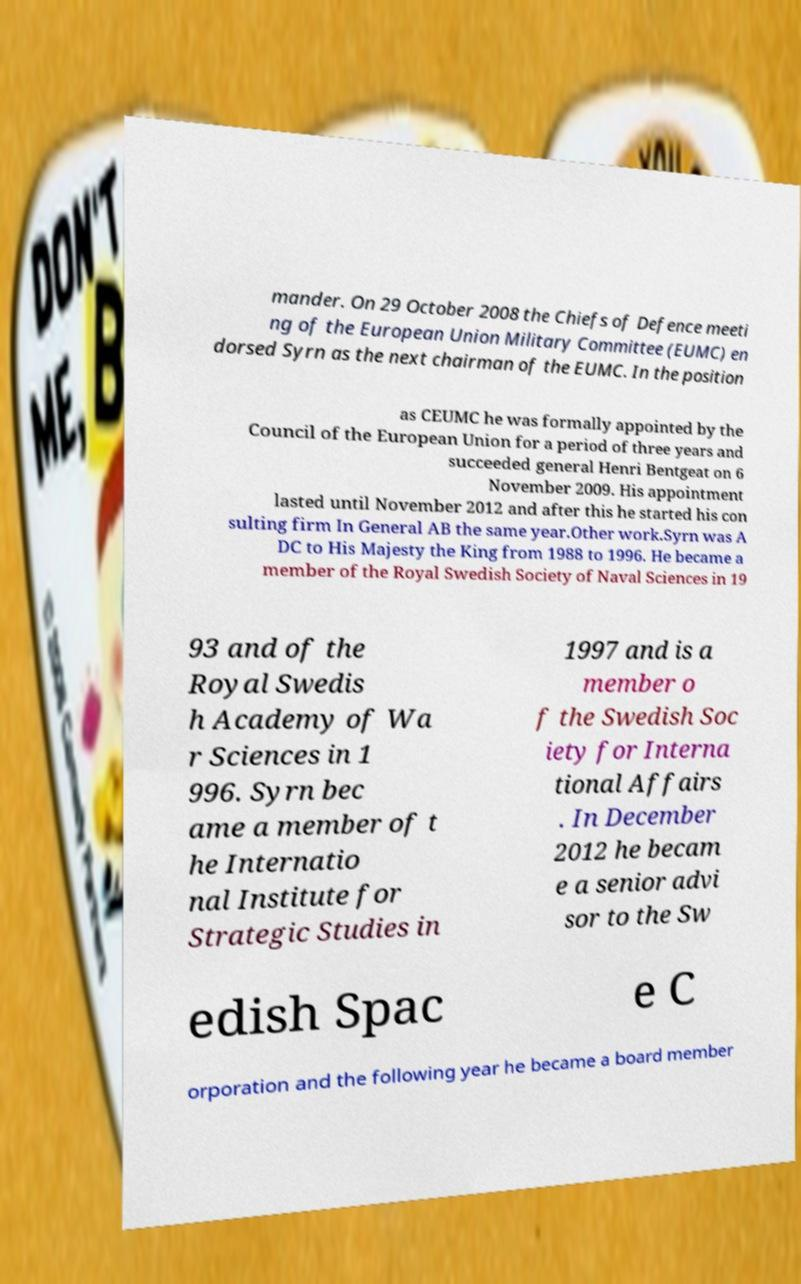For documentation purposes, I need the text within this image transcribed. Could you provide that? mander. On 29 October 2008 the Chiefs of Defence meeti ng of the European Union Military Committee (EUMC) en dorsed Syrn as the next chairman of the EUMC. In the position as CEUMC he was formally appointed by the Council of the European Union for a period of three years and succeeded general Henri Bentgeat on 6 November 2009. His appointment lasted until November 2012 and after this he started his con sulting firm In General AB the same year.Other work.Syrn was A DC to His Majesty the King from 1988 to 1996. He became a member of the Royal Swedish Society of Naval Sciences in 19 93 and of the Royal Swedis h Academy of Wa r Sciences in 1 996. Syrn bec ame a member of t he Internatio nal Institute for Strategic Studies in 1997 and is a member o f the Swedish Soc iety for Interna tional Affairs . In December 2012 he becam e a senior advi sor to the Sw edish Spac e C orporation and the following year he became a board member 